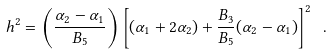<formula> <loc_0><loc_0><loc_500><loc_500>h ^ { 2 } = \left ( \frac { \alpha _ { 2 } - \alpha _ { 1 } } { B _ { 5 } } \right ) \left [ ( \alpha _ { 1 } + 2 \alpha _ { 2 } ) + \frac { B _ { 3 } } { B _ { 5 } } ( \alpha _ { 2 } - \alpha _ { 1 } ) \right ] ^ { 2 } \ .</formula> 